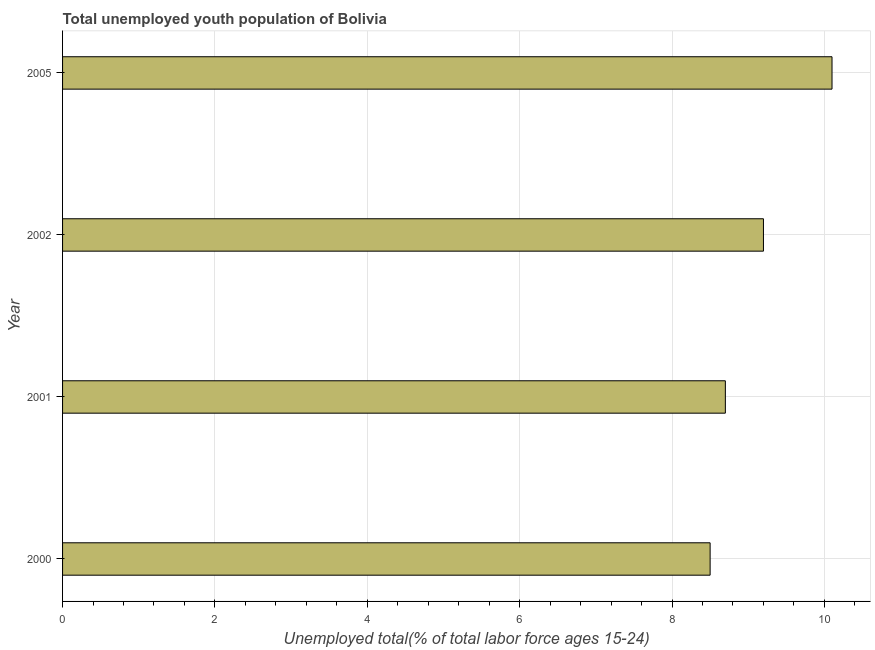Does the graph contain any zero values?
Offer a very short reply. No. Does the graph contain grids?
Provide a succinct answer. Yes. What is the title of the graph?
Provide a short and direct response. Total unemployed youth population of Bolivia. What is the label or title of the X-axis?
Your answer should be very brief. Unemployed total(% of total labor force ages 15-24). What is the unemployed youth in 2002?
Offer a terse response. 9.2. Across all years, what is the maximum unemployed youth?
Offer a very short reply. 10.1. Across all years, what is the minimum unemployed youth?
Offer a very short reply. 8.5. In which year was the unemployed youth maximum?
Your answer should be compact. 2005. What is the sum of the unemployed youth?
Your response must be concise. 36.5. What is the difference between the unemployed youth in 2000 and 2002?
Make the answer very short. -0.7. What is the average unemployed youth per year?
Your answer should be very brief. 9.12. What is the median unemployed youth?
Your answer should be very brief. 8.95. Do a majority of the years between 2000 and 2001 (inclusive) have unemployed youth greater than 5.2 %?
Provide a short and direct response. Yes. What is the ratio of the unemployed youth in 2002 to that in 2005?
Your answer should be very brief. 0.91. Is the unemployed youth in 2001 less than that in 2002?
Make the answer very short. Yes. Is the sum of the unemployed youth in 2002 and 2005 greater than the maximum unemployed youth across all years?
Your answer should be very brief. Yes. What is the difference between the highest and the lowest unemployed youth?
Your answer should be very brief. 1.6. In how many years, is the unemployed youth greater than the average unemployed youth taken over all years?
Give a very brief answer. 2. How many bars are there?
Provide a short and direct response. 4. What is the difference between two consecutive major ticks on the X-axis?
Provide a short and direct response. 2. Are the values on the major ticks of X-axis written in scientific E-notation?
Offer a terse response. No. What is the Unemployed total(% of total labor force ages 15-24) in 2000?
Your answer should be compact. 8.5. What is the Unemployed total(% of total labor force ages 15-24) in 2001?
Keep it short and to the point. 8.7. What is the Unemployed total(% of total labor force ages 15-24) in 2002?
Your answer should be very brief. 9.2. What is the Unemployed total(% of total labor force ages 15-24) in 2005?
Make the answer very short. 10.1. What is the difference between the Unemployed total(% of total labor force ages 15-24) in 2000 and 2001?
Offer a terse response. -0.2. What is the difference between the Unemployed total(% of total labor force ages 15-24) in 2000 and 2002?
Offer a terse response. -0.7. What is the difference between the Unemployed total(% of total labor force ages 15-24) in 2000 and 2005?
Provide a succinct answer. -1.6. What is the difference between the Unemployed total(% of total labor force ages 15-24) in 2001 and 2005?
Provide a succinct answer. -1.4. What is the ratio of the Unemployed total(% of total labor force ages 15-24) in 2000 to that in 2001?
Your answer should be compact. 0.98. What is the ratio of the Unemployed total(% of total labor force ages 15-24) in 2000 to that in 2002?
Provide a succinct answer. 0.92. What is the ratio of the Unemployed total(% of total labor force ages 15-24) in 2000 to that in 2005?
Keep it short and to the point. 0.84. What is the ratio of the Unemployed total(% of total labor force ages 15-24) in 2001 to that in 2002?
Keep it short and to the point. 0.95. What is the ratio of the Unemployed total(% of total labor force ages 15-24) in 2001 to that in 2005?
Provide a succinct answer. 0.86. What is the ratio of the Unemployed total(% of total labor force ages 15-24) in 2002 to that in 2005?
Make the answer very short. 0.91. 